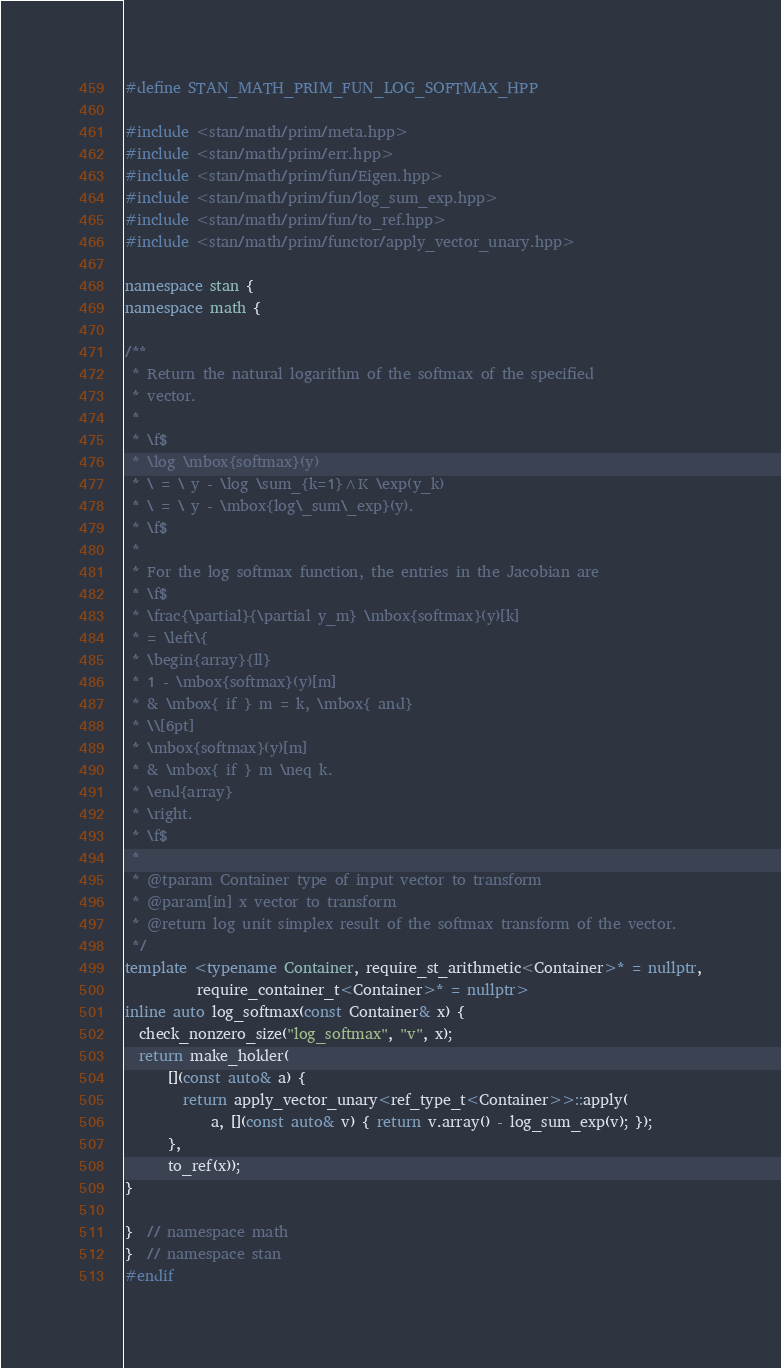<code> <loc_0><loc_0><loc_500><loc_500><_C++_>#define STAN_MATH_PRIM_FUN_LOG_SOFTMAX_HPP

#include <stan/math/prim/meta.hpp>
#include <stan/math/prim/err.hpp>
#include <stan/math/prim/fun/Eigen.hpp>
#include <stan/math/prim/fun/log_sum_exp.hpp>
#include <stan/math/prim/fun/to_ref.hpp>
#include <stan/math/prim/functor/apply_vector_unary.hpp>

namespace stan {
namespace math {

/**
 * Return the natural logarithm of the softmax of the specified
 * vector.
 *
 * \f$
 * \log \mbox{softmax}(y)
 * \ = \ y - \log \sum_{k=1}^K \exp(y_k)
 * \ = \ y - \mbox{log\_sum\_exp}(y).
 * \f$
 *
 * For the log softmax function, the entries in the Jacobian are
 * \f$
 * \frac{\partial}{\partial y_m} \mbox{softmax}(y)[k]
 * = \left\{
 * \begin{array}{ll}
 * 1 - \mbox{softmax}(y)[m]
 * & \mbox{ if } m = k, \mbox{ and}
 * \\[6pt]
 * \mbox{softmax}(y)[m]
 * & \mbox{ if } m \neq k.
 * \end{array}
 * \right.
 * \f$
 *
 * @tparam Container type of input vector to transform
 * @param[in] x vector to transform
 * @return log unit simplex result of the softmax transform of the vector.
 */
template <typename Container, require_st_arithmetic<Container>* = nullptr,
          require_container_t<Container>* = nullptr>
inline auto log_softmax(const Container& x) {
  check_nonzero_size("log_softmax", "v", x);
  return make_holder(
      [](const auto& a) {
        return apply_vector_unary<ref_type_t<Container>>::apply(
            a, [](const auto& v) { return v.array() - log_sum_exp(v); });
      },
      to_ref(x));
}

}  // namespace math
}  // namespace stan
#endif
</code> 